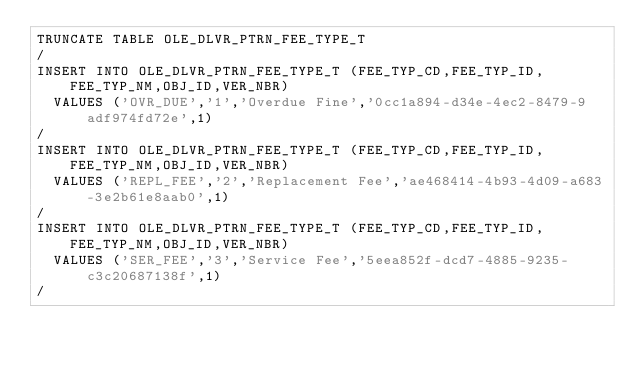Convert code to text. <code><loc_0><loc_0><loc_500><loc_500><_SQL_>TRUNCATE TABLE OLE_DLVR_PTRN_FEE_TYPE_T
/
INSERT INTO OLE_DLVR_PTRN_FEE_TYPE_T (FEE_TYP_CD,FEE_TYP_ID,FEE_TYP_NM,OBJ_ID,VER_NBR)
  VALUES ('OVR_DUE','1','Overdue Fine','0cc1a894-d34e-4ec2-8479-9adf974fd72e',1)
/
INSERT INTO OLE_DLVR_PTRN_FEE_TYPE_T (FEE_TYP_CD,FEE_TYP_ID,FEE_TYP_NM,OBJ_ID,VER_NBR)
  VALUES ('REPL_FEE','2','Replacement Fee','ae468414-4b93-4d09-a683-3e2b61e8aab0',1)
/
INSERT INTO OLE_DLVR_PTRN_FEE_TYPE_T (FEE_TYP_CD,FEE_TYP_ID,FEE_TYP_NM,OBJ_ID,VER_NBR)
  VALUES ('SER_FEE','3','Service Fee','5eea852f-dcd7-4885-9235-c3c20687138f',1)
/
</code> 